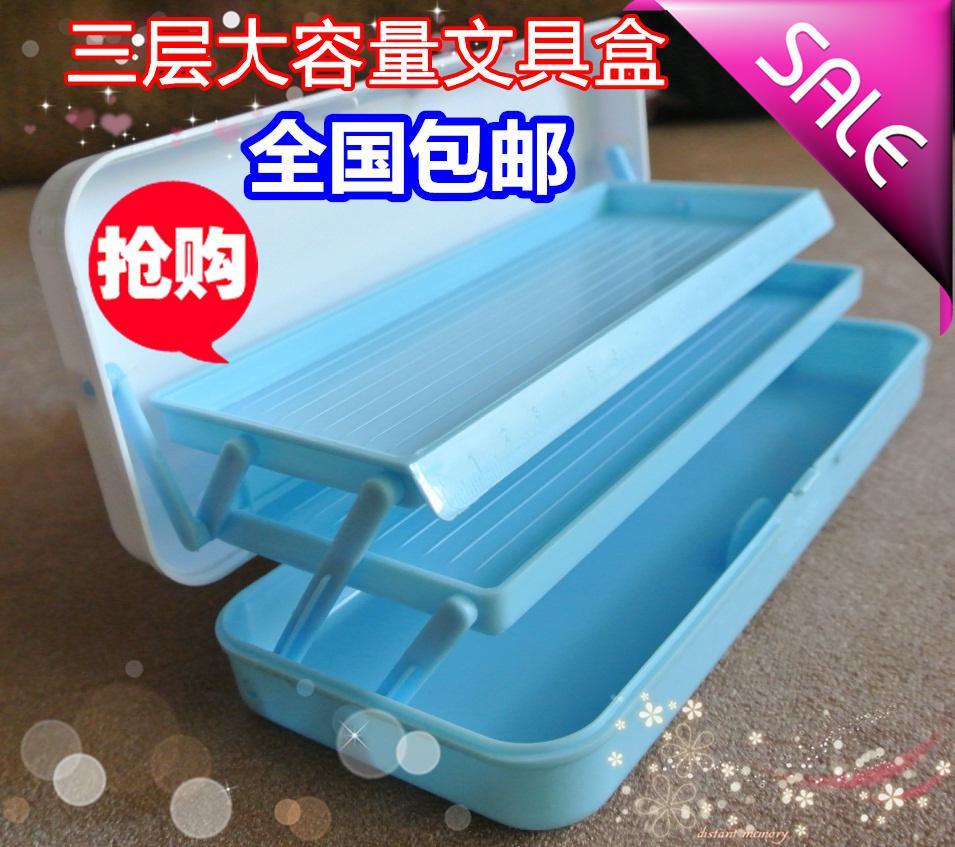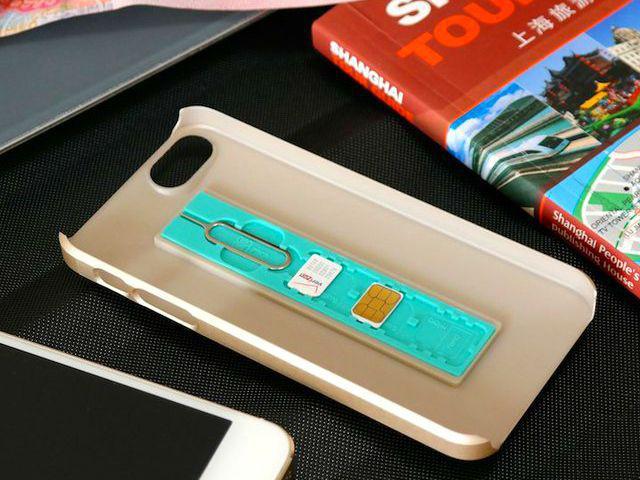The first image is the image on the left, the second image is the image on the right. Analyze the images presented: Is the assertion "At least one of the cases is closed." valid? Answer yes or no. No. 